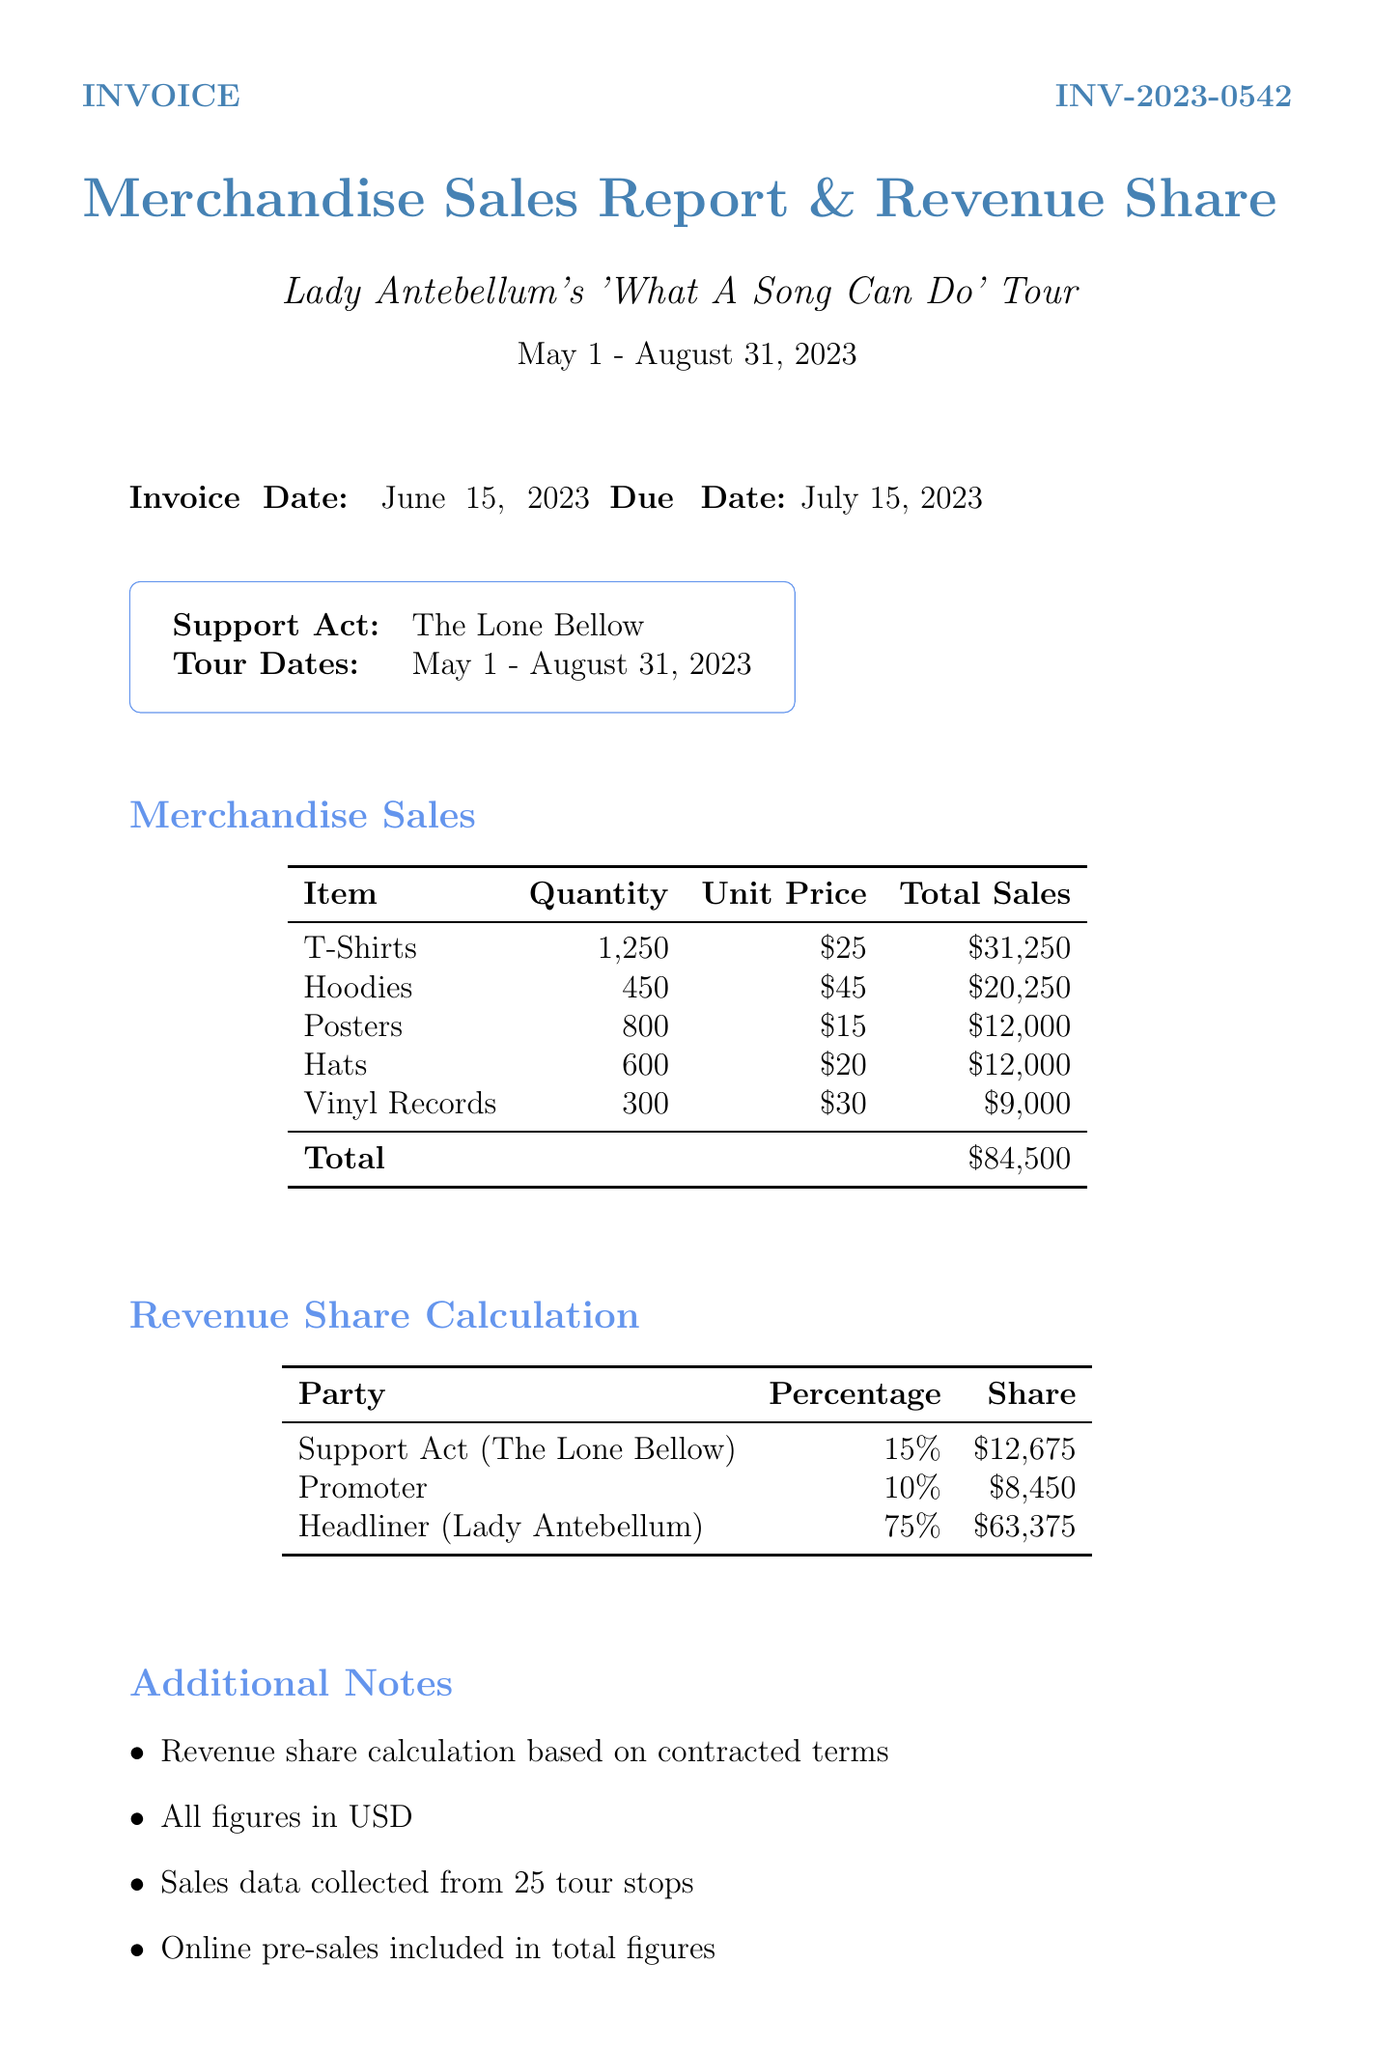What is the invoice number? The invoice number is specifically listed in the document under invoice details.
Answer: INV-2023-0542 What is the total merchandise sales amount? The total merchandise sales amount is provided in the merchandise sales section of the document.
Answer: $84,500 What is the support act percentage? The support act percentage is listed in the revenue share calculation section of the document.
Answer: 15% Who is the promoter's contact person? The promoter's contact person is mentioned in the contact information section of the document.
Answer: Sarah Johnson How many tour stops were sales data collected from? The number of tour stops for sales data collection is stated in the additional notes section.
Answer: 25 What item generated the highest revenue? Highest revenue is determined by comparing total sales amounts for each item listed.
Answer: T-Shirts What is the due date for the invoice? The due date for the invoice is included in the invoice details section.
Answer: July 15, 2023 What bank is the payment payable to? The bank the payment is payable to is specified in the payment instructions section.
Answer: Chase Bank 